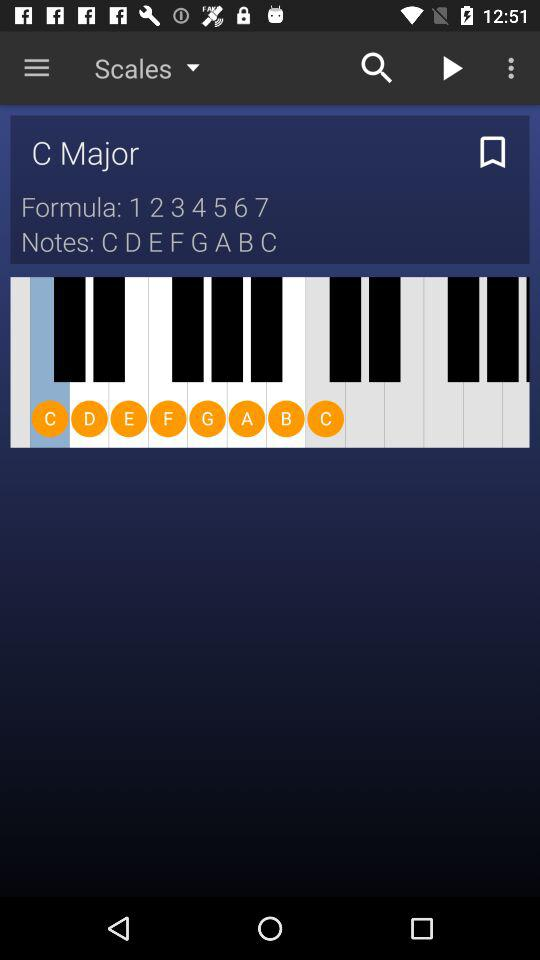What are the "Notes"? The "Notes" are C, D, E, F, G, A, B and C. 